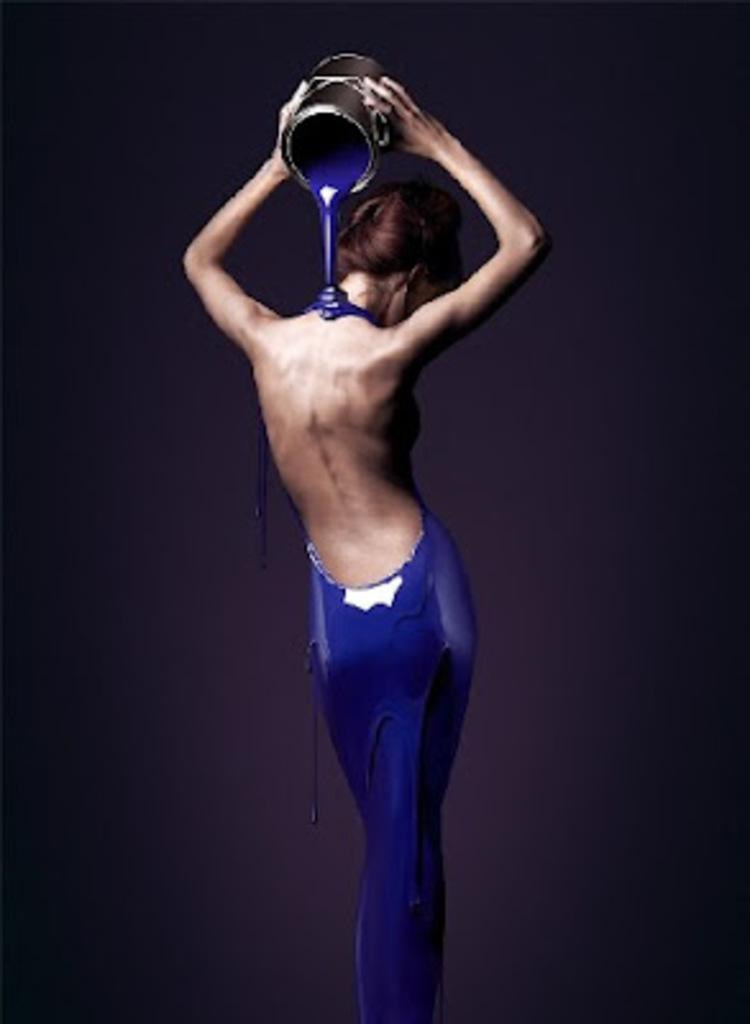What is the main subject of the image? The main subject of the image is a person standing in the center. What is the person holding in the image? The person is holding a pot in the image. What is the person doing with the pot? The person is pouring blue color paint on his body with the pot. What can be observed about the background of the image? The background of the image is dark. What type of vacation is the person discussing with others in the image? There is no indication of a discussion or vacation in the image; the person is pouring blue color paint on his body with a pot. 